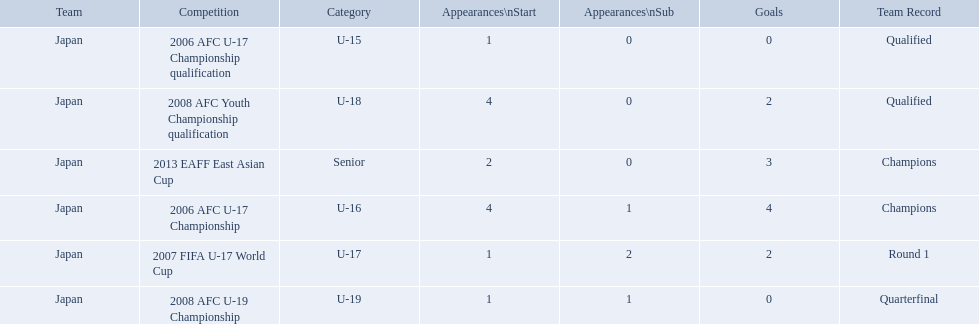Which competitions had champions team records? 2006 AFC U-17 Championship, 2013 EAFF East Asian Cup. Of these competitions, which one was in the senior category? 2013 EAFF East Asian Cup. 